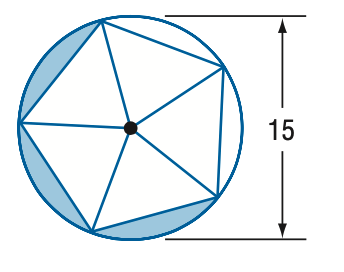Answer the mathemtical geometry problem and directly provide the correct option letter.
Question: Find the area of the shaded region. Assume the inscribed polygon is regular.
Choices: A: 8.6 B: 17.2 C: 25.8 D: 44.4 C 